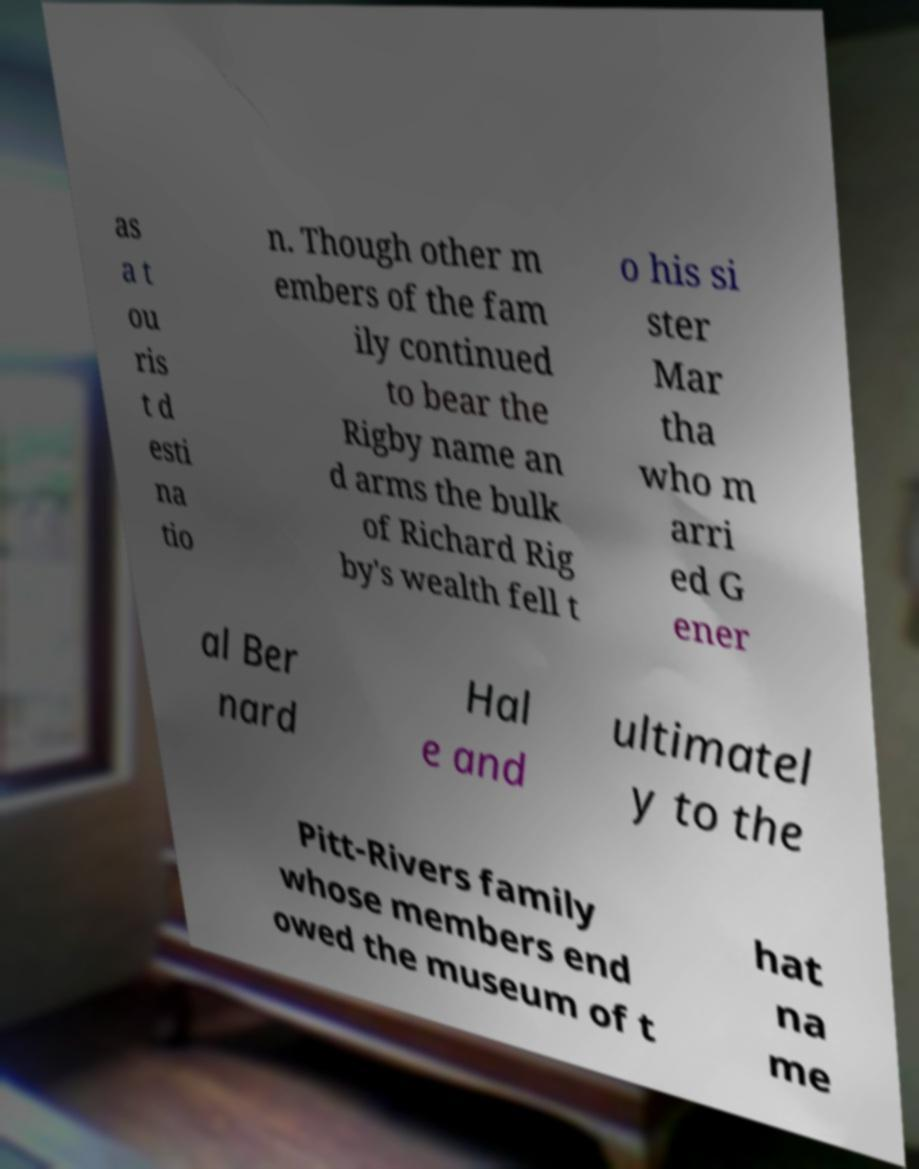I need the written content from this picture converted into text. Can you do that? as a t ou ris t d esti na tio n. Though other m embers of the fam ily continued to bear the Rigby name an d arms the bulk of Richard Rig by's wealth fell t o his si ster Mar tha who m arri ed G ener al Ber nard Hal e and ultimatel y to the Pitt-Rivers family whose members end owed the museum of t hat na me 